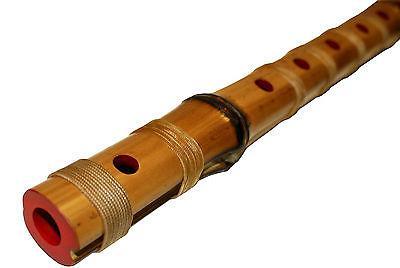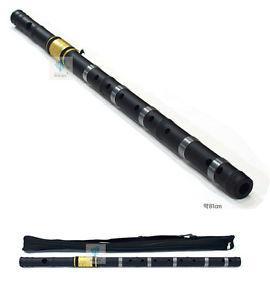The first image is the image on the left, the second image is the image on the right. Examine the images to the left and right. Is the description "Three or fewer flutes are visible." accurate? Answer yes or no. Yes. The first image is the image on the left, the second image is the image on the right. For the images displayed, is the sentence "There appears to be four flutes." factually correct? Answer yes or no. Yes. 